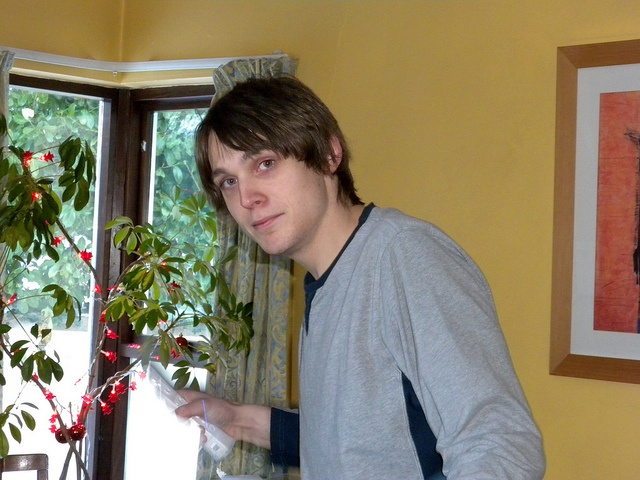Describe the objects in this image and their specific colors. I can see people in olive, darkgray, black, and gray tones, potted plant in olive, white, black, darkgreen, and gray tones, remote in olive, lightgray, and darkgray tones, and chair in olive, gray, white, darkgray, and maroon tones in this image. 